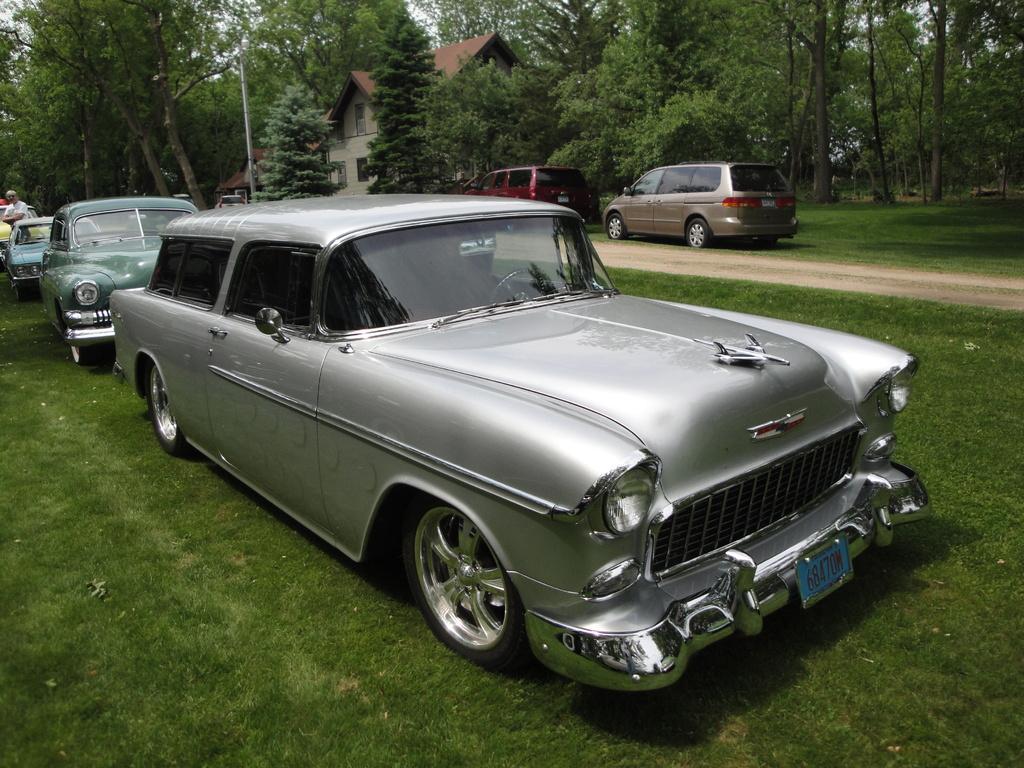Please provide a concise description of this image. In the image there are some vehicles. Behind the vehicles there are some trees and buildings and poles. At the bottom of the image there is grass. Behind the vehicles there's a man is standing. 